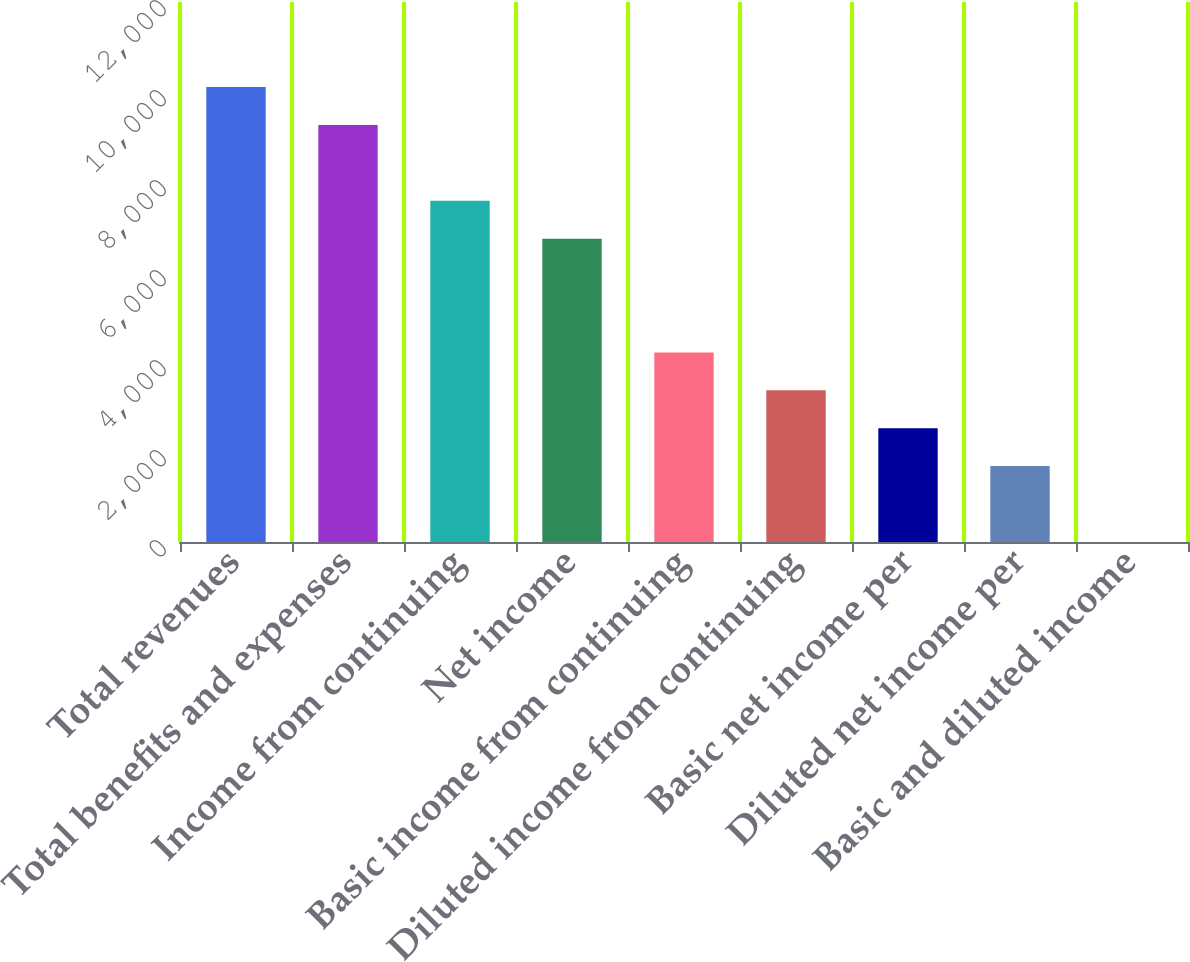Convert chart. <chart><loc_0><loc_0><loc_500><loc_500><bar_chart><fcel>Total revenues<fcel>Total benefits and expenses<fcel>Income from continuing<fcel>Net income<fcel>Basic income from continuing<fcel>Diluted income from continuing<fcel>Basic net income per<fcel>Diluted net income per<fcel>Basic and diluted income<nl><fcel>10109.7<fcel>9267.35<fcel>7582.65<fcel>6740.3<fcel>4213.25<fcel>3370.9<fcel>2528.55<fcel>1686.2<fcel>1.5<nl></chart> 